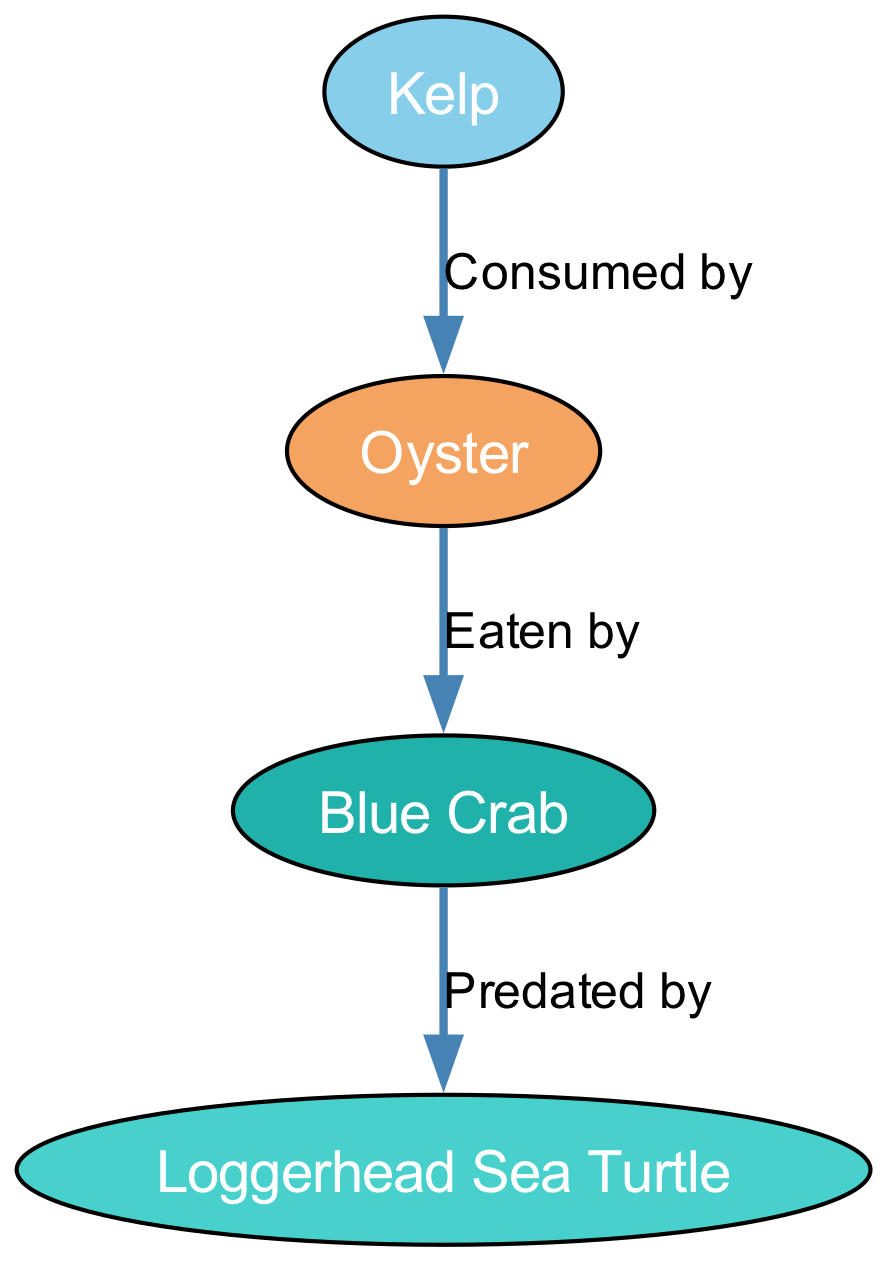What is the base of the food chain in this diagram? The base of the food chain is typically the first producer or primary source of energy, which is represented by the node for Kelp (seaweed). Thus, Kelp is at the bottom of this food chain diagram.
Answer: Kelp How many nodes are present in the food chain? By counting the individual nodes listed in the diagram: Kelp, Blue Crab, Oyster, and Loggerhead Sea Turtle, there are a total of four distinct nodes.
Answer: 4 What is the relationship between Kelp and Oyster? The diagram indicates that Kelp is consumed by Oyster, which establishes a clear predation relationship where Kelp serves as a food source for the Oyster.
Answer: Consumed by Which animal preys on Blue Crabs? The edges in the diagram show that Blue Crabs are predated by Loggerhead Sea Turtle, so the Loggerhead Sea Turtle is the animal that preys on Blue Crabs in this food chain.
Answer: Loggerhead Sea Turtle What type of organism is the Loggerhead Sea Turtle in relation to the food chain? In the context of the diagram, Loggerhead Sea Turtle acts as a predator, meaning it is at the top of this specific food chain as it preys on Blue Crabs, which are further down.
Answer: Predator What do Mollusks eat in this food chain? Referring to the relationships outlined in the diagram, Mollusks (Oyster) have Kelp as their food source, meaning Mollusks eat Kelp as part of their diet.
Answer: Kelp How many total edges are there in the food chain? To find the total number of edges, we refer to the connections in the diagram: Kelp to Oyster, Oyster to Blue Crab, and Blue Crab to Loggerhead Sea Turtle, which adds up to three edges.
Answer: 3 What is the role of Crustaceans in this food chain? Crustaceans (Blue Crab) occupy a position as consumers, eating Mollusks (Oysters), thereby playing a role as primary consumers in this food chain structure.
Answer: Primary consumers 